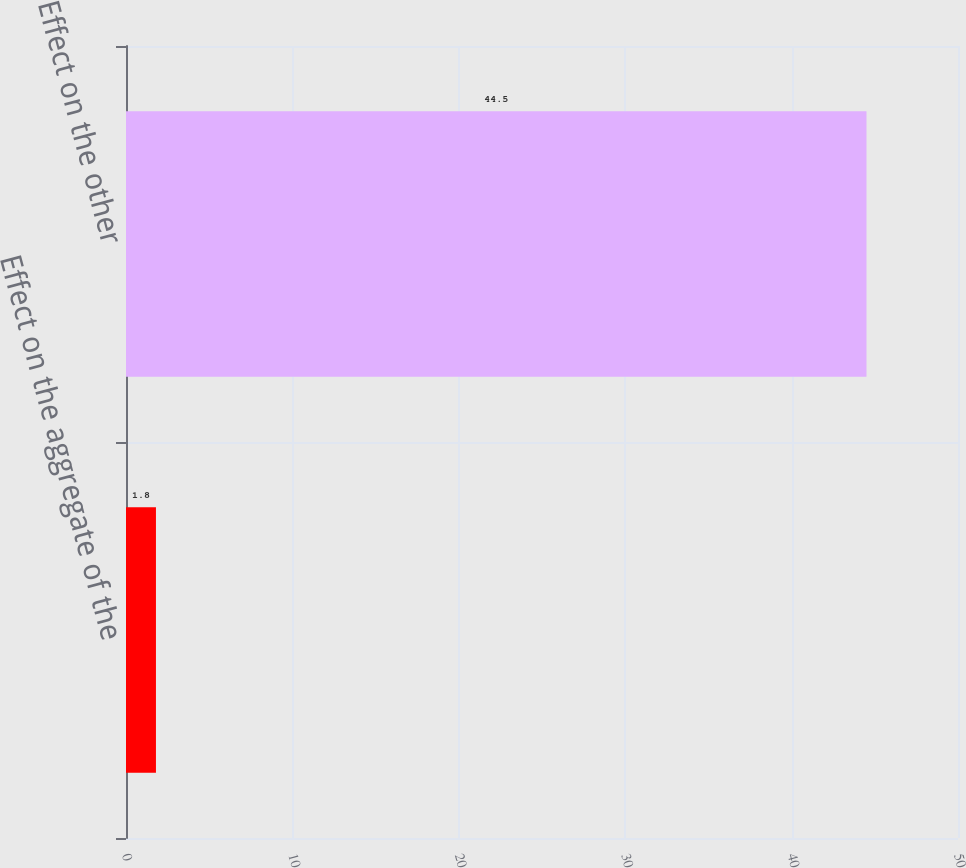Convert chart. <chart><loc_0><loc_0><loc_500><loc_500><bar_chart><fcel>Effect on the aggregate of the<fcel>Effect on the other<nl><fcel>1.8<fcel>44.5<nl></chart> 